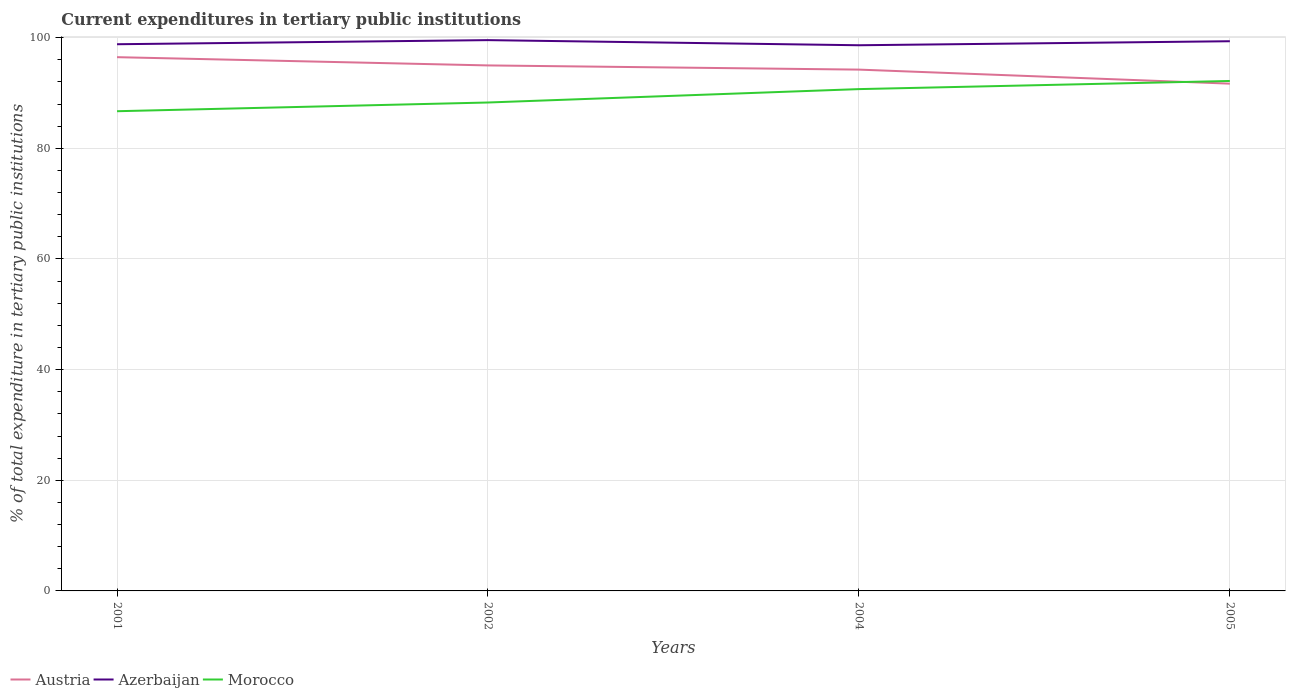How many different coloured lines are there?
Your answer should be very brief. 3. Does the line corresponding to Austria intersect with the line corresponding to Azerbaijan?
Make the answer very short. No. Is the number of lines equal to the number of legend labels?
Your answer should be compact. Yes. Across all years, what is the maximum current expenditures in tertiary public institutions in Austria?
Your answer should be very brief. 91.69. What is the total current expenditures in tertiary public institutions in Morocco in the graph?
Make the answer very short. -3.89. What is the difference between the highest and the second highest current expenditures in tertiary public institutions in Morocco?
Your response must be concise. 5.47. What is the difference between the highest and the lowest current expenditures in tertiary public institutions in Austria?
Offer a very short reply. 2. What is the difference between two consecutive major ticks on the Y-axis?
Ensure brevity in your answer.  20. Does the graph contain any zero values?
Your response must be concise. No. How many legend labels are there?
Offer a very short reply. 3. How are the legend labels stacked?
Your answer should be very brief. Horizontal. What is the title of the graph?
Provide a succinct answer. Current expenditures in tertiary public institutions. What is the label or title of the X-axis?
Your response must be concise. Years. What is the label or title of the Y-axis?
Provide a succinct answer. % of total expenditure in tertiary public institutions. What is the % of total expenditure in tertiary public institutions in Austria in 2001?
Make the answer very short. 96.48. What is the % of total expenditure in tertiary public institutions in Azerbaijan in 2001?
Ensure brevity in your answer.  98.82. What is the % of total expenditure in tertiary public institutions in Morocco in 2001?
Provide a succinct answer. 86.71. What is the % of total expenditure in tertiary public institutions in Austria in 2002?
Your answer should be compact. 94.99. What is the % of total expenditure in tertiary public institutions of Azerbaijan in 2002?
Give a very brief answer. 99.56. What is the % of total expenditure in tertiary public institutions of Morocco in 2002?
Ensure brevity in your answer.  88.29. What is the % of total expenditure in tertiary public institutions of Austria in 2004?
Ensure brevity in your answer.  94.23. What is the % of total expenditure in tertiary public institutions in Azerbaijan in 2004?
Your answer should be very brief. 98.64. What is the % of total expenditure in tertiary public institutions of Morocco in 2004?
Your answer should be compact. 90.71. What is the % of total expenditure in tertiary public institutions of Austria in 2005?
Offer a very short reply. 91.69. What is the % of total expenditure in tertiary public institutions in Azerbaijan in 2005?
Offer a terse response. 99.36. What is the % of total expenditure in tertiary public institutions of Morocco in 2005?
Make the answer very short. 92.18. Across all years, what is the maximum % of total expenditure in tertiary public institutions in Austria?
Your response must be concise. 96.48. Across all years, what is the maximum % of total expenditure in tertiary public institutions of Azerbaijan?
Ensure brevity in your answer.  99.56. Across all years, what is the maximum % of total expenditure in tertiary public institutions of Morocco?
Your response must be concise. 92.18. Across all years, what is the minimum % of total expenditure in tertiary public institutions in Austria?
Provide a succinct answer. 91.69. Across all years, what is the minimum % of total expenditure in tertiary public institutions in Azerbaijan?
Make the answer very short. 98.64. Across all years, what is the minimum % of total expenditure in tertiary public institutions of Morocco?
Keep it short and to the point. 86.71. What is the total % of total expenditure in tertiary public institutions of Austria in the graph?
Your response must be concise. 377.4. What is the total % of total expenditure in tertiary public institutions in Azerbaijan in the graph?
Give a very brief answer. 396.38. What is the total % of total expenditure in tertiary public institutions in Morocco in the graph?
Offer a very short reply. 357.89. What is the difference between the % of total expenditure in tertiary public institutions in Austria in 2001 and that in 2002?
Provide a short and direct response. 1.49. What is the difference between the % of total expenditure in tertiary public institutions of Azerbaijan in 2001 and that in 2002?
Ensure brevity in your answer.  -0.74. What is the difference between the % of total expenditure in tertiary public institutions in Morocco in 2001 and that in 2002?
Provide a short and direct response. -1.57. What is the difference between the % of total expenditure in tertiary public institutions in Austria in 2001 and that in 2004?
Make the answer very short. 2.25. What is the difference between the % of total expenditure in tertiary public institutions in Azerbaijan in 2001 and that in 2004?
Keep it short and to the point. 0.18. What is the difference between the % of total expenditure in tertiary public institutions of Morocco in 2001 and that in 2004?
Keep it short and to the point. -4. What is the difference between the % of total expenditure in tertiary public institutions in Austria in 2001 and that in 2005?
Provide a succinct answer. 4.79. What is the difference between the % of total expenditure in tertiary public institutions of Azerbaijan in 2001 and that in 2005?
Provide a succinct answer. -0.54. What is the difference between the % of total expenditure in tertiary public institutions in Morocco in 2001 and that in 2005?
Give a very brief answer. -5.47. What is the difference between the % of total expenditure in tertiary public institutions in Austria in 2002 and that in 2004?
Ensure brevity in your answer.  0.76. What is the difference between the % of total expenditure in tertiary public institutions in Azerbaijan in 2002 and that in 2004?
Your answer should be very brief. 0.93. What is the difference between the % of total expenditure in tertiary public institutions in Morocco in 2002 and that in 2004?
Your answer should be compact. -2.42. What is the difference between the % of total expenditure in tertiary public institutions of Austria in 2002 and that in 2005?
Your answer should be very brief. 3.3. What is the difference between the % of total expenditure in tertiary public institutions in Azerbaijan in 2002 and that in 2005?
Provide a short and direct response. 0.2. What is the difference between the % of total expenditure in tertiary public institutions of Morocco in 2002 and that in 2005?
Provide a short and direct response. -3.89. What is the difference between the % of total expenditure in tertiary public institutions of Austria in 2004 and that in 2005?
Make the answer very short. 2.54. What is the difference between the % of total expenditure in tertiary public institutions of Azerbaijan in 2004 and that in 2005?
Your answer should be compact. -0.72. What is the difference between the % of total expenditure in tertiary public institutions in Morocco in 2004 and that in 2005?
Provide a short and direct response. -1.47. What is the difference between the % of total expenditure in tertiary public institutions in Austria in 2001 and the % of total expenditure in tertiary public institutions in Azerbaijan in 2002?
Your response must be concise. -3.08. What is the difference between the % of total expenditure in tertiary public institutions in Austria in 2001 and the % of total expenditure in tertiary public institutions in Morocco in 2002?
Make the answer very short. 8.19. What is the difference between the % of total expenditure in tertiary public institutions of Azerbaijan in 2001 and the % of total expenditure in tertiary public institutions of Morocco in 2002?
Your response must be concise. 10.53. What is the difference between the % of total expenditure in tertiary public institutions in Austria in 2001 and the % of total expenditure in tertiary public institutions in Azerbaijan in 2004?
Offer a terse response. -2.15. What is the difference between the % of total expenditure in tertiary public institutions in Austria in 2001 and the % of total expenditure in tertiary public institutions in Morocco in 2004?
Your answer should be very brief. 5.77. What is the difference between the % of total expenditure in tertiary public institutions of Azerbaijan in 2001 and the % of total expenditure in tertiary public institutions of Morocco in 2004?
Make the answer very short. 8.11. What is the difference between the % of total expenditure in tertiary public institutions of Austria in 2001 and the % of total expenditure in tertiary public institutions of Azerbaijan in 2005?
Ensure brevity in your answer.  -2.88. What is the difference between the % of total expenditure in tertiary public institutions of Austria in 2001 and the % of total expenditure in tertiary public institutions of Morocco in 2005?
Give a very brief answer. 4.3. What is the difference between the % of total expenditure in tertiary public institutions in Azerbaijan in 2001 and the % of total expenditure in tertiary public institutions in Morocco in 2005?
Give a very brief answer. 6.64. What is the difference between the % of total expenditure in tertiary public institutions of Austria in 2002 and the % of total expenditure in tertiary public institutions of Azerbaijan in 2004?
Ensure brevity in your answer.  -3.65. What is the difference between the % of total expenditure in tertiary public institutions of Austria in 2002 and the % of total expenditure in tertiary public institutions of Morocco in 2004?
Make the answer very short. 4.28. What is the difference between the % of total expenditure in tertiary public institutions in Azerbaijan in 2002 and the % of total expenditure in tertiary public institutions in Morocco in 2004?
Your answer should be compact. 8.85. What is the difference between the % of total expenditure in tertiary public institutions of Austria in 2002 and the % of total expenditure in tertiary public institutions of Azerbaijan in 2005?
Keep it short and to the point. -4.37. What is the difference between the % of total expenditure in tertiary public institutions of Austria in 2002 and the % of total expenditure in tertiary public institutions of Morocco in 2005?
Ensure brevity in your answer.  2.81. What is the difference between the % of total expenditure in tertiary public institutions in Azerbaijan in 2002 and the % of total expenditure in tertiary public institutions in Morocco in 2005?
Keep it short and to the point. 7.38. What is the difference between the % of total expenditure in tertiary public institutions in Austria in 2004 and the % of total expenditure in tertiary public institutions in Azerbaijan in 2005?
Provide a short and direct response. -5.13. What is the difference between the % of total expenditure in tertiary public institutions of Austria in 2004 and the % of total expenditure in tertiary public institutions of Morocco in 2005?
Provide a short and direct response. 2.05. What is the difference between the % of total expenditure in tertiary public institutions of Azerbaijan in 2004 and the % of total expenditure in tertiary public institutions of Morocco in 2005?
Your answer should be compact. 6.46. What is the average % of total expenditure in tertiary public institutions of Austria per year?
Provide a succinct answer. 94.35. What is the average % of total expenditure in tertiary public institutions in Azerbaijan per year?
Your answer should be compact. 99.1. What is the average % of total expenditure in tertiary public institutions in Morocco per year?
Offer a very short reply. 89.47. In the year 2001, what is the difference between the % of total expenditure in tertiary public institutions of Austria and % of total expenditure in tertiary public institutions of Azerbaijan?
Your answer should be very brief. -2.34. In the year 2001, what is the difference between the % of total expenditure in tertiary public institutions in Austria and % of total expenditure in tertiary public institutions in Morocco?
Offer a very short reply. 9.77. In the year 2001, what is the difference between the % of total expenditure in tertiary public institutions in Azerbaijan and % of total expenditure in tertiary public institutions in Morocco?
Your response must be concise. 12.11. In the year 2002, what is the difference between the % of total expenditure in tertiary public institutions of Austria and % of total expenditure in tertiary public institutions of Azerbaijan?
Your response must be concise. -4.57. In the year 2002, what is the difference between the % of total expenditure in tertiary public institutions of Austria and % of total expenditure in tertiary public institutions of Morocco?
Provide a succinct answer. 6.7. In the year 2002, what is the difference between the % of total expenditure in tertiary public institutions in Azerbaijan and % of total expenditure in tertiary public institutions in Morocco?
Offer a terse response. 11.27. In the year 2004, what is the difference between the % of total expenditure in tertiary public institutions in Austria and % of total expenditure in tertiary public institutions in Azerbaijan?
Offer a terse response. -4.4. In the year 2004, what is the difference between the % of total expenditure in tertiary public institutions of Austria and % of total expenditure in tertiary public institutions of Morocco?
Keep it short and to the point. 3.53. In the year 2004, what is the difference between the % of total expenditure in tertiary public institutions in Azerbaijan and % of total expenditure in tertiary public institutions in Morocco?
Your answer should be very brief. 7.93. In the year 2005, what is the difference between the % of total expenditure in tertiary public institutions in Austria and % of total expenditure in tertiary public institutions in Azerbaijan?
Offer a terse response. -7.67. In the year 2005, what is the difference between the % of total expenditure in tertiary public institutions in Austria and % of total expenditure in tertiary public institutions in Morocco?
Ensure brevity in your answer.  -0.49. In the year 2005, what is the difference between the % of total expenditure in tertiary public institutions of Azerbaijan and % of total expenditure in tertiary public institutions of Morocco?
Your response must be concise. 7.18. What is the ratio of the % of total expenditure in tertiary public institutions in Austria in 2001 to that in 2002?
Offer a terse response. 1.02. What is the ratio of the % of total expenditure in tertiary public institutions in Morocco in 2001 to that in 2002?
Provide a short and direct response. 0.98. What is the ratio of the % of total expenditure in tertiary public institutions of Austria in 2001 to that in 2004?
Give a very brief answer. 1.02. What is the ratio of the % of total expenditure in tertiary public institutions in Morocco in 2001 to that in 2004?
Your answer should be compact. 0.96. What is the ratio of the % of total expenditure in tertiary public institutions of Austria in 2001 to that in 2005?
Ensure brevity in your answer.  1.05. What is the ratio of the % of total expenditure in tertiary public institutions of Azerbaijan in 2001 to that in 2005?
Provide a short and direct response. 0.99. What is the ratio of the % of total expenditure in tertiary public institutions of Morocco in 2001 to that in 2005?
Make the answer very short. 0.94. What is the ratio of the % of total expenditure in tertiary public institutions of Austria in 2002 to that in 2004?
Keep it short and to the point. 1.01. What is the ratio of the % of total expenditure in tertiary public institutions in Azerbaijan in 2002 to that in 2004?
Keep it short and to the point. 1.01. What is the ratio of the % of total expenditure in tertiary public institutions of Morocco in 2002 to that in 2004?
Offer a terse response. 0.97. What is the ratio of the % of total expenditure in tertiary public institutions in Austria in 2002 to that in 2005?
Provide a succinct answer. 1.04. What is the ratio of the % of total expenditure in tertiary public institutions in Morocco in 2002 to that in 2005?
Offer a very short reply. 0.96. What is the ratio of the % of total expenditure in tertiary public institutions of Austria in 2004 to that in 2005?
Provide a succinct answer. 1.03. What is the ratio of the % of total expenditure in tertiary public institutions of Azerbaijan in 2004 to that in 2005?
Offer a very short reply. 0.99. What is the ratio of the % of total expenditure in tertiary public institutions of Morocco in 2004 to that in 2005?
Provide a short and direct response. 0.98. What is the difference between the highest and the second highest % of total expenditure in tertiary public institutions of Austria?
Provide a succinct answer. 1.49. What is the difference between the highest and the second highest % of total expenditure in tertiary public institutions in Azerbaijan?
Keep it short and to the point. 0.2. What is the difference between the highest and the second highest % of total expenditure in tertiary public institutions of Morocco?
Your answer should be very brief. 1.47. What is the difference between the highest and the lowest % of total expenditure in tertiary public institutions of Austria?
Offer a terse response. 4.79. What is the difference between the highest and the lowest % of total expenditure in tertiary public institutions in Azerbaijan?
Your answer should be very brief. 0.93. What is the difference between the highest and the lowest % of total expenditure in tertiary public institutions of Morocco?
Ensure brevity in your answer.  5.47. 